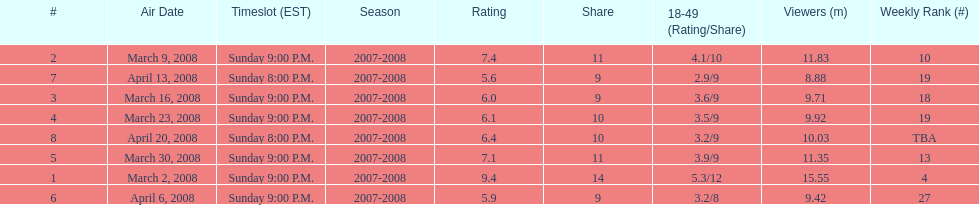How many shows had at least 10 million viewers? 4. 